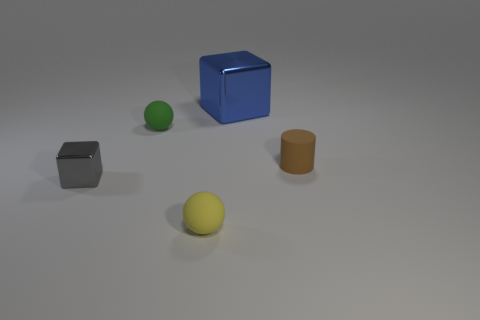There is a tiny green thing; are there any big blue blocks to the right of it?
Your answer should be very brief. Yes. What number of yellow objects are either tiny rubber cylinders or small cubes?
Your answer should be compact. 0. Are the tiny yellow thing and the tiny ball that is behind the gray shiny block made of the same material?
Your response must be concise. Yes. What is the size of the other matte object that is the same shape as the tiny green thing?
Provide a succinct answer. Small. What is the material of the yellow object?
Your response must be concise. Rubber. What is the material of the cube that is behind the rubber ball that is behind the metal thing on the left side of the small green thing?
Offer a very short reply. Metal. Does the matte thing that is left of the yellow rubber sphere have the same size as the rubber object that is in front of the tiny rubber cylinder?
Offer a very short reply. Yes. What number of other objects are the same material as the gray object?
Your answer should be compact. 1. How many metal objects are blue cubes or tiny purple objects?
Your response must be concise. 1. Is the number of small cyan balls less than the number of yellow objects?
Provide a succinct answer. Yes. 